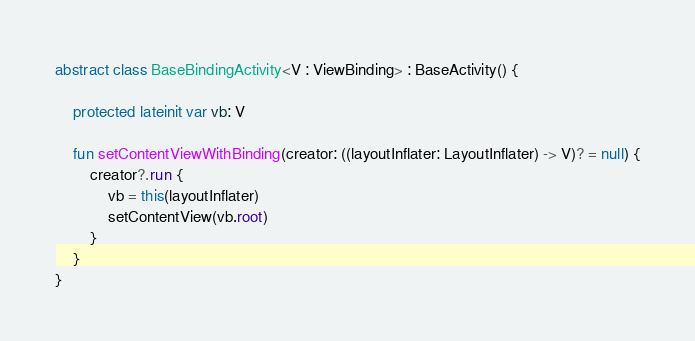Convert code to text. <code><loc_0><loc_0><loc_500><loc_500><_Kotlin_>abstract class BaseBindingActivity<V : ViewBinding> : BaseActivity() {

    protected lateinit var vb: V

    fun setContentViewWithBinding(creator: ((layoutInflater: LayoutInflater) -> V)? = null) {
        creator?.run {
            vb = this(layoutInflater)
            setContentView(vb.root)
        }
    }
}</code> 